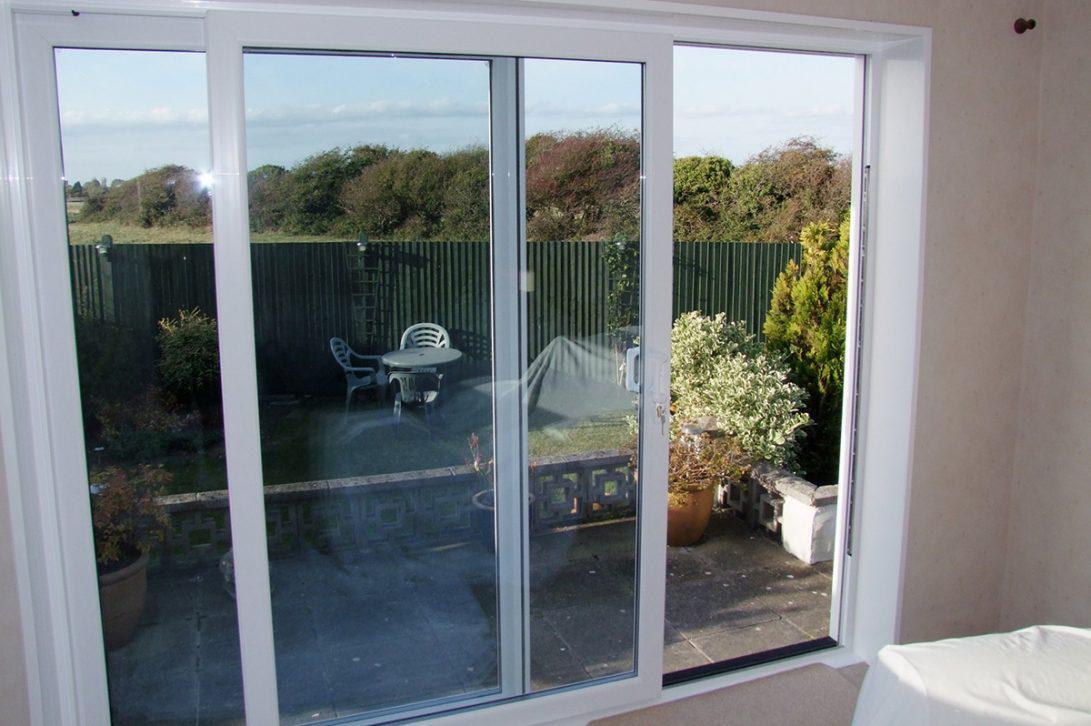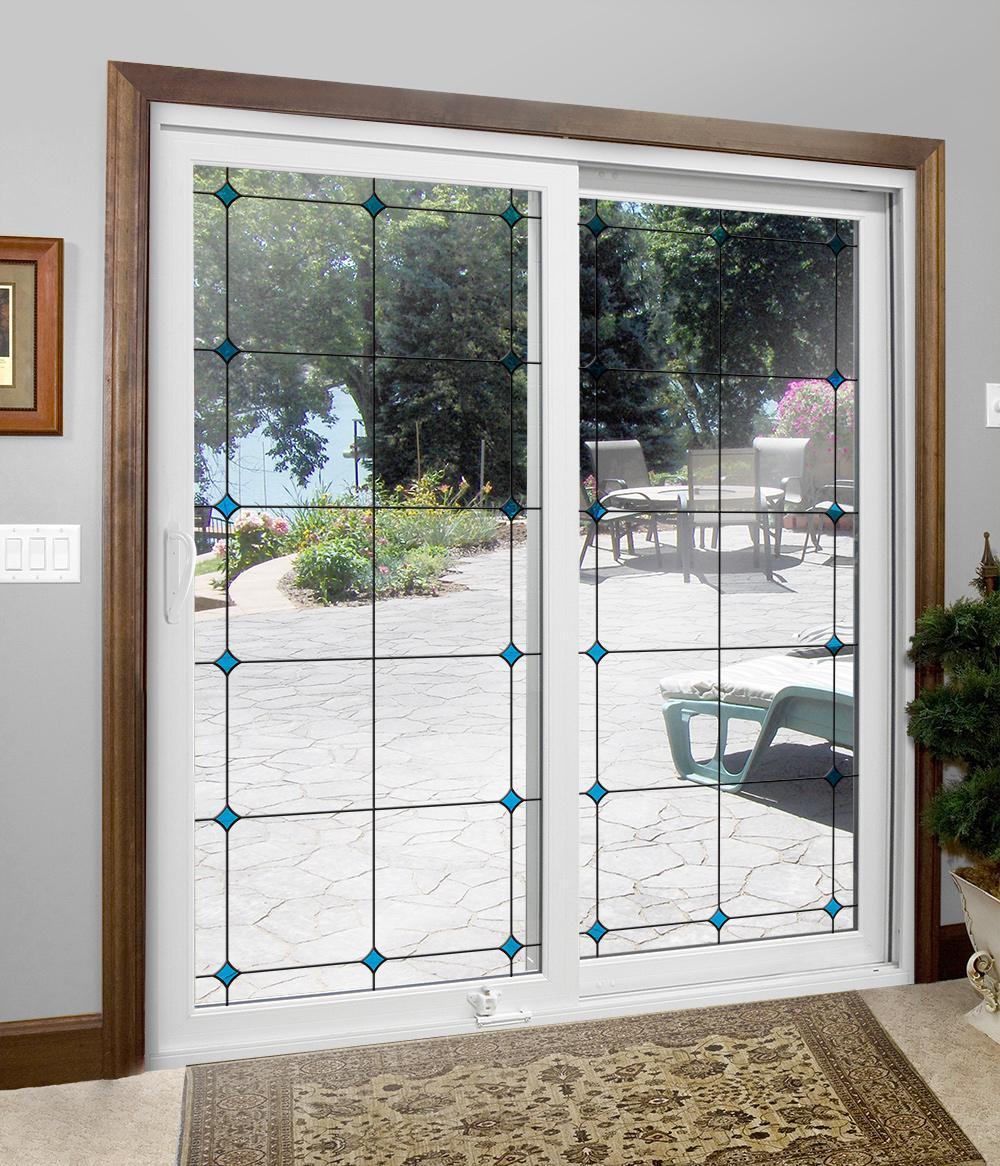The first image is the image on the left, the second image is the image on the right. Examine the images to the left and right. Is the description "All the doors are closed." accurate? Answer yes or no. No. The first image is the image on the left, the second image is the image on the right. Assess this claim about the two images: "The image on the left has a white wood-trimmed glass door.". Correct or not? Answer yes or no. Yes. 